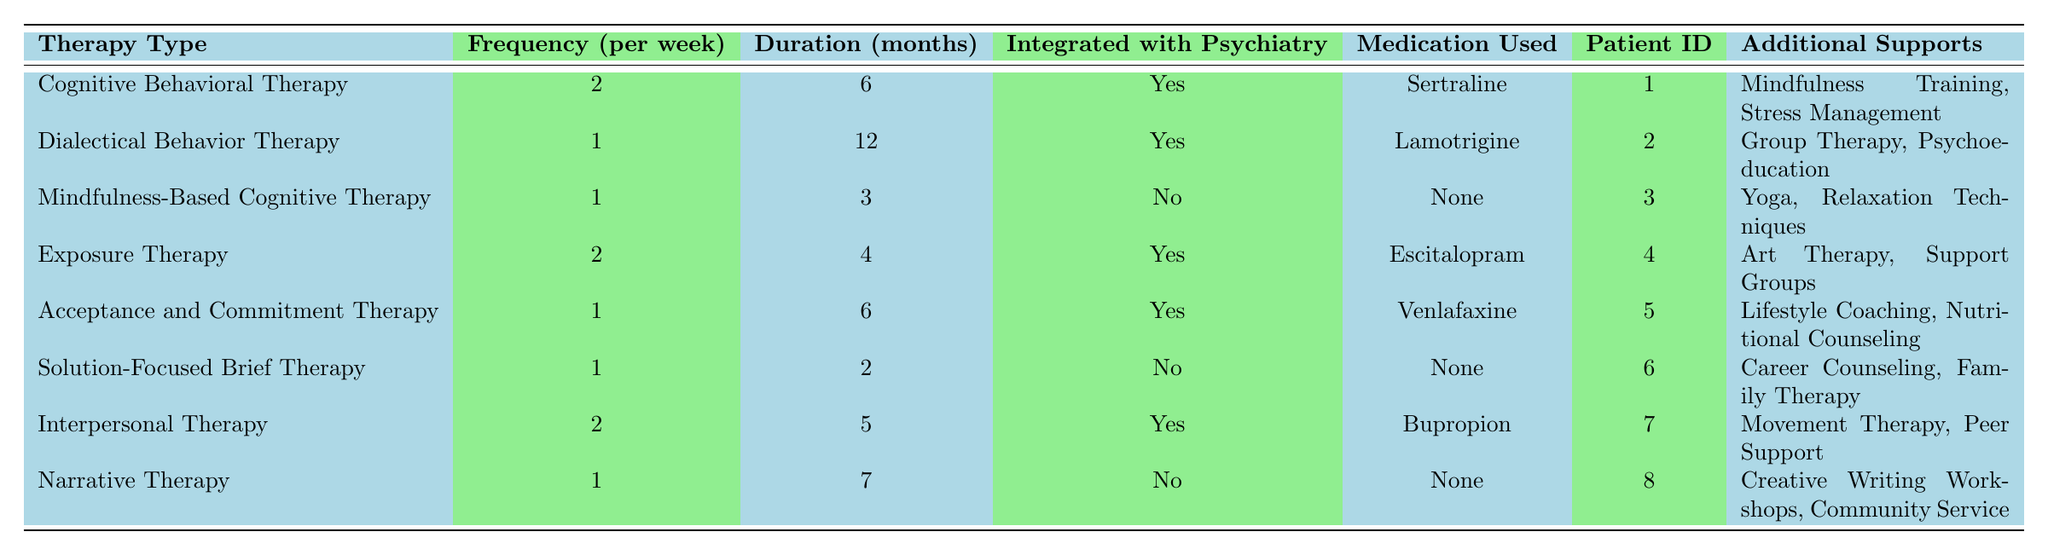What is the therapy type with the highest frequency per week? By examining the "Frequency (per week)" column, both "Cognitive Behavioral Therapy" and "Interpersonal Therapy" have a frequency of 2 sessions per week, which is the highest in the table.
Answer: Cognitive Behavioral Therapy, Interpersonal Therapy How many patients are using "Mindfulness-Based Cognitive Therapy"? Referring to the table, there is only one entry for "Mindfulness-Based Cognitive Therapy," corresponding to patient ID 3.
Answer: 1 Which therapy modality has the longest duration in months? The maximum value in the "Duration (months)" column is 12, associated with "Dialectical Behavior Therapy," which indicates it has the longest duration.
Answer: Dialectical Behavior Therapy What percentage of therapies are integrated with psychiatry? There are a total of 8 therapy types listed, 5 of which are integrated with psychiatry (Cognitive Behavioral Therapy, Dialectical Behavior Therapy, Exposure Therapy, Acceptance and Commitment Therapy, Interpersonal Therapy). Therefore, the percentage is (5/8)*100 = 62.5%.
Answer: 62.5% How many patients are using medication compared to those not using medication? By counting, 6 patients are using medication (Cognitive Behavioral Therapy, Dialectical Behavior Therapy, Exposure Therapy, Acceptance and Commitment Therapy, Interpersonal Therapy) and 2 patients are not using medication (Mindfulness-Based Cognitive Therapy, Solution-Focused Brief Therapy, Narrative Therapy). There are more patients using medication.
Answer: More patients are using medication Is there any patient using both "Mindfulness Training" and medication? The only patient listed with "Mindfulness Training" is patient ID 1, who is using "Sertraline" as medication. Thus, this is a true statement.
Answer: Yes What is the average frequency of therapy sessions per week across all therapies? To find the average frequency, sum the frequencies: (2 + 1 + 1 + 2 + 1 + 1 + 2 + 1) = 11. There are 8 sessions, so the average is 11/8 = 1.375.
Answer: 1.375 List the therapy types that include "Group Therapy" as an additional support. By examining the "Additional Supports" column, only "Dialectical Behavior Therapy" includes "Group Therapy." Therefore, that is the only entry.
Answer: Dialectical Behavior Therapy Is any therapy type integrated with psychiatry that does not use any medication? Referring to the table, all integrated therapies (Cognitive Behavioral Therapy, Dialectical Behavior Therapy, Exposure Therapy, Acceptance and Commitment Therapy, Interpersonal Therapy) have a medication listed. Therefore, the answer is no.
Answer: No Which additional support is used by the most patients in this data? "Mindfulness Training" appears for 1 patient, "Group Therapy" for 1 patient, "Yoga" for 1 patient, "Art Therapy" for 1 patient, "Lifestyle Coaching" for 1 patient, "Career Counseling" for 1 patient, "Movement Therapy" for 1 patient, and "Creative Writing Workshops" for 1 patient. All additional supports are used by 1 patient each, thus no one support is more frequent than the others.
Answer: None (all are used by 1 patient each) 